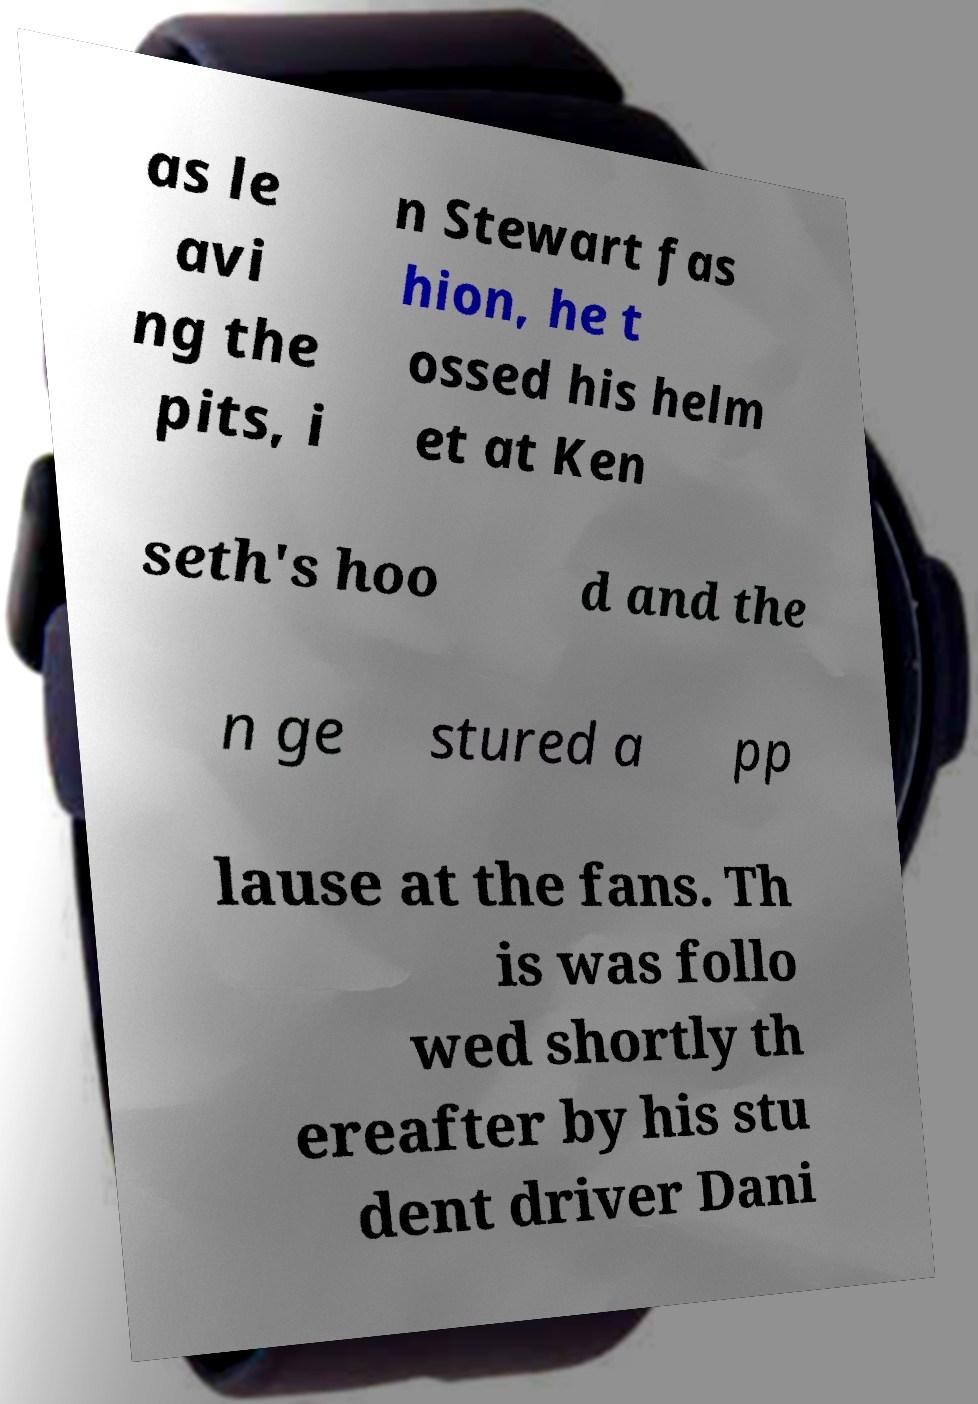Can you accurately transcribe the text from the provided image for me? as le avi ng the pits, i n Stewart fas hion, he t ossed his helm et at Ken seth's hoo d and the n ge stured a pp lause at the fans. Th is was follo wed shortly th ereafter by his stu dent driver Dani 